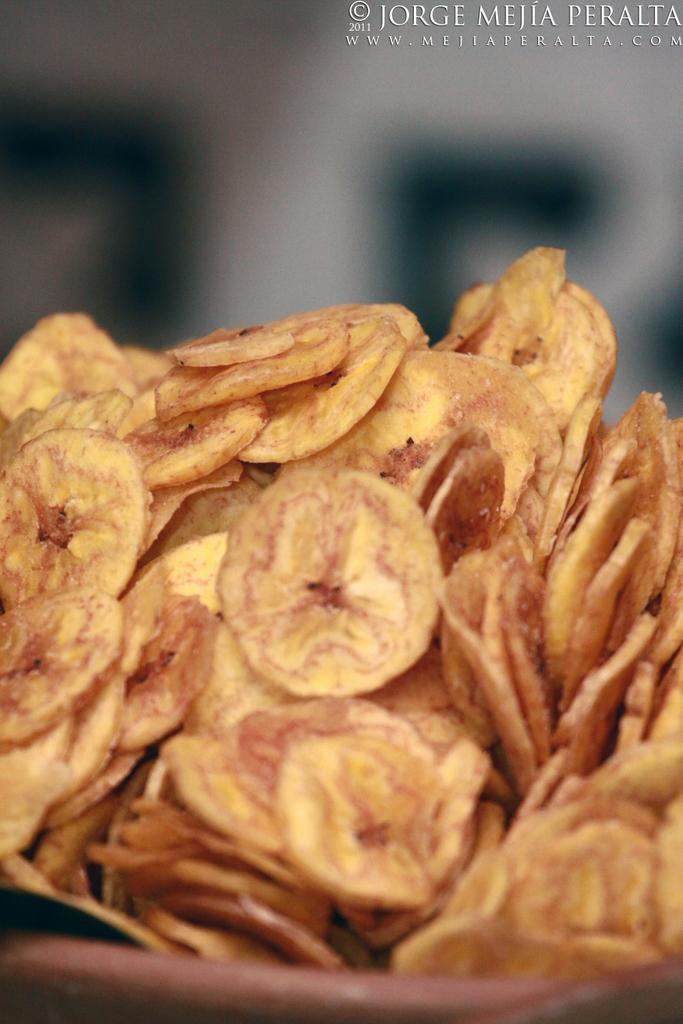How would you summarize this image in a sentence or two? In this image we can see banana chips. 